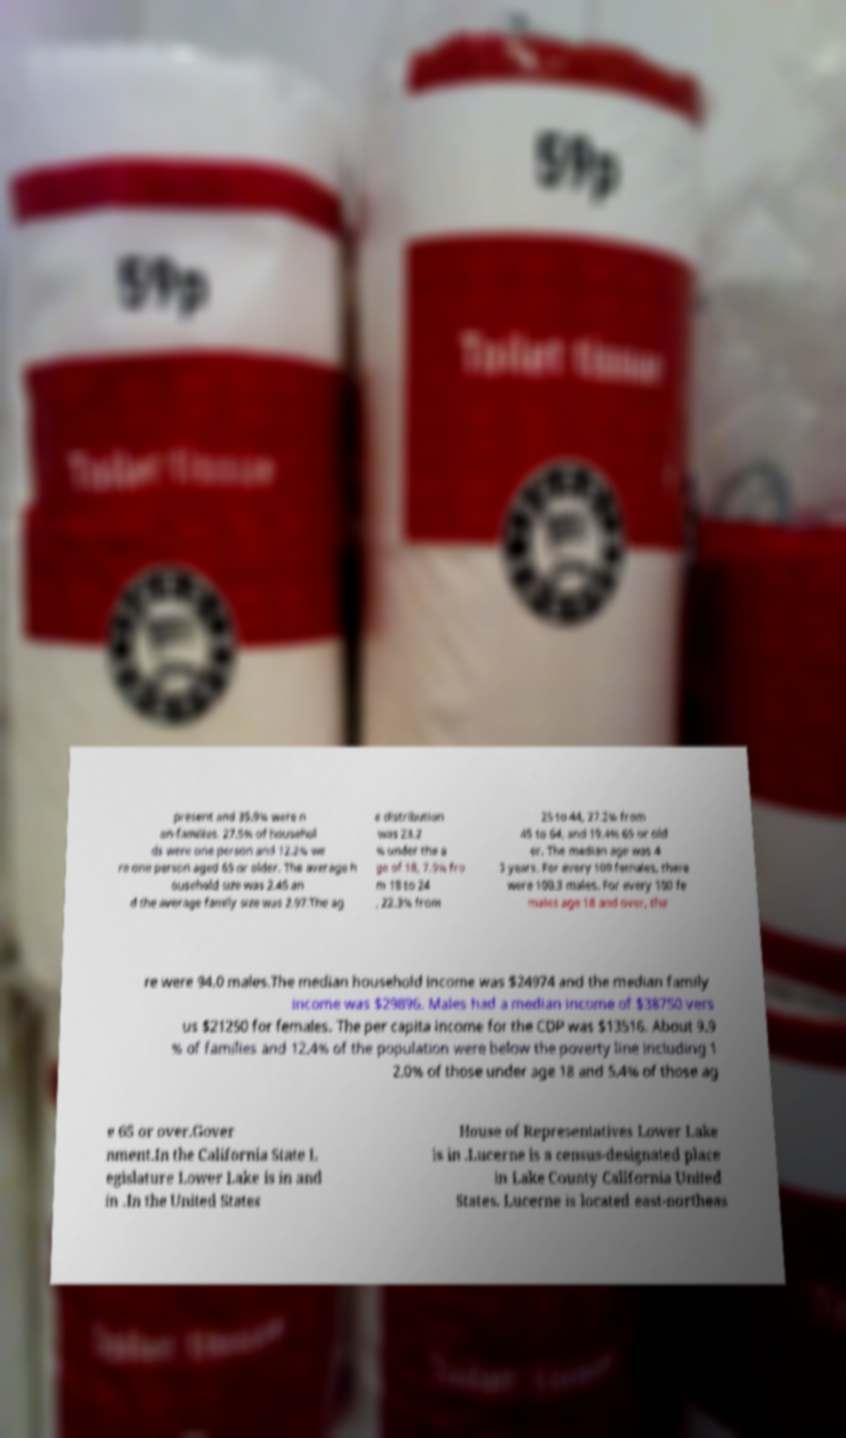I need the written content from this picture converted into text. Can you do that? present and 35.9% were n on-families. 27.5% of househol ds were one person and 12.2% we re one person aged 65 or older. The average h ousehold size was 2.45 an d the average family size was 2.97.The ag e distribution was 23.2 % under the a ge of 18, 7.9% fro m 18 to 24 , 22.3% from 25 to 44, 27.2% from 45 to 64, and 19.4% 65 or old er. The median age was 4 3 years. For every 100 females, there were 100.3 males. For every 100 fe males age 18 and over, the re were 94.0 males.The median household income was $24974 and the median family income was $29896. Males had a median income of $38750 vers us $21250 for females. The per capita income for the CDP was $13516. About 9.9 % of families and 12.4% of the population were below the poverty line including 1 2.0% of those under age 18 and 5.4% of those ag e 65 or over.Gover nment.In the California State L egislature Lower Lake is in and in .In the United States House of Representatives Lower Lake is in .Lucerne is a census-designated place in Lake County California United States. Lucerne is located east-northeas 